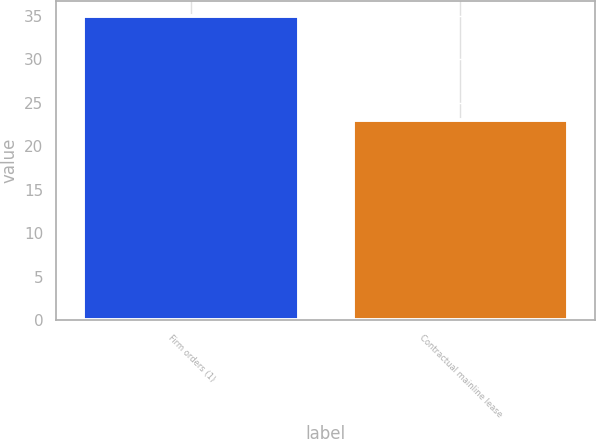<chart> <loc_0><loc_0><loc_500><loc_500><bar_chart><fcel>Firm orders (1)<fcel>Contractual mainline lease<nl><fcel>35<fcel>23<nl></chart> 